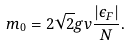<formula> <loc_0><loc_0><loc_500><loc_500>m _ { 0 } = 2 \sqrt { 2 } g v \frac { | \epsilon _ { F } | } { N } .</formula> 